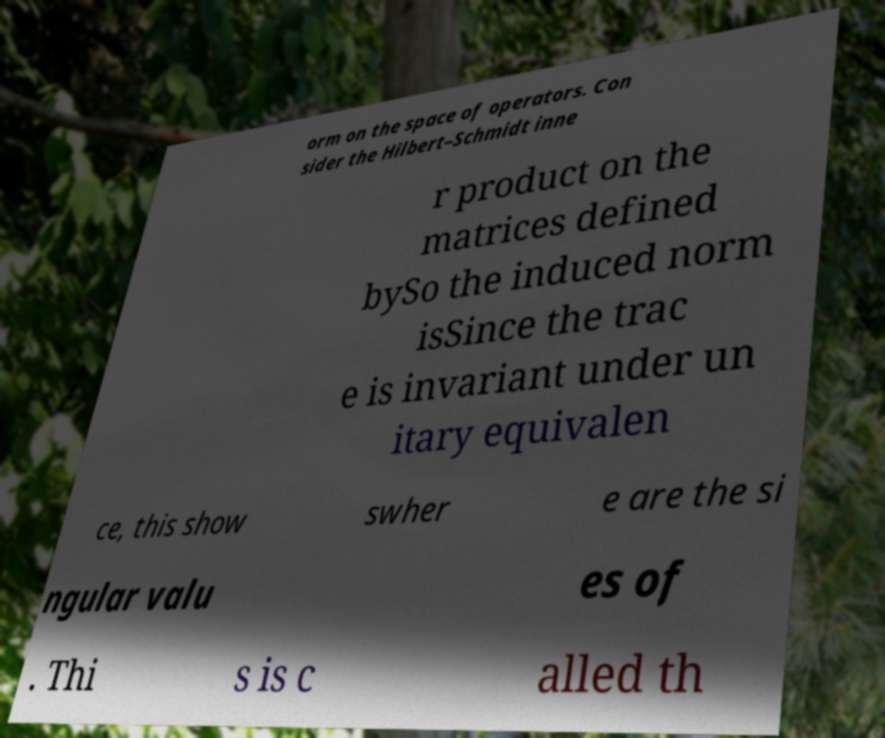Can you read and provide the text displayed in the image?This photo seems to have some interesting text. Can you extract and type it out for me? orm on the space of operators. Con sider the Hilbert–Schmidt inne r product on the matrices defined bySo the induced norm isSince the trac e is invariant under un itary equivalen ce, this show swher e are the si ngular valu es of . Thi s is c alled th 